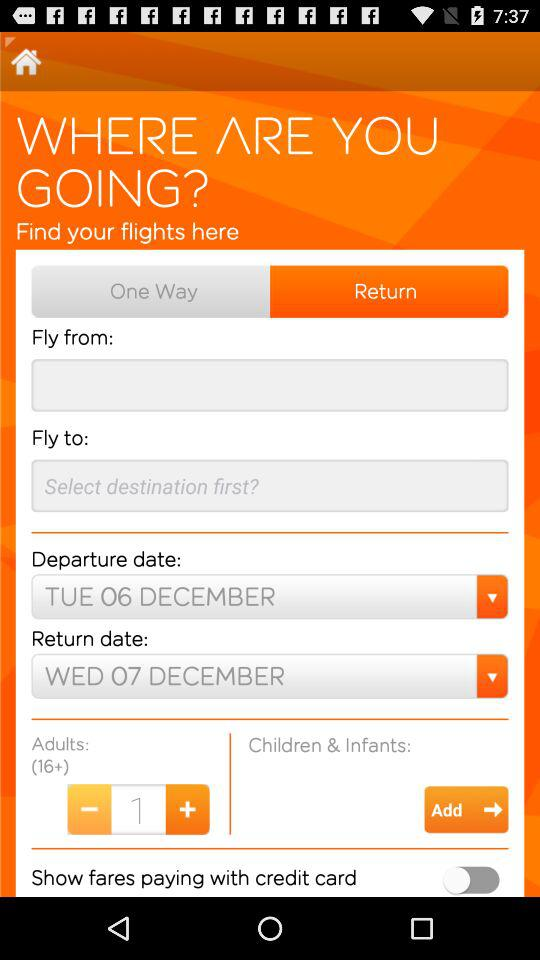What is the status of "Show fares paying with credit card"? The status is "off". 